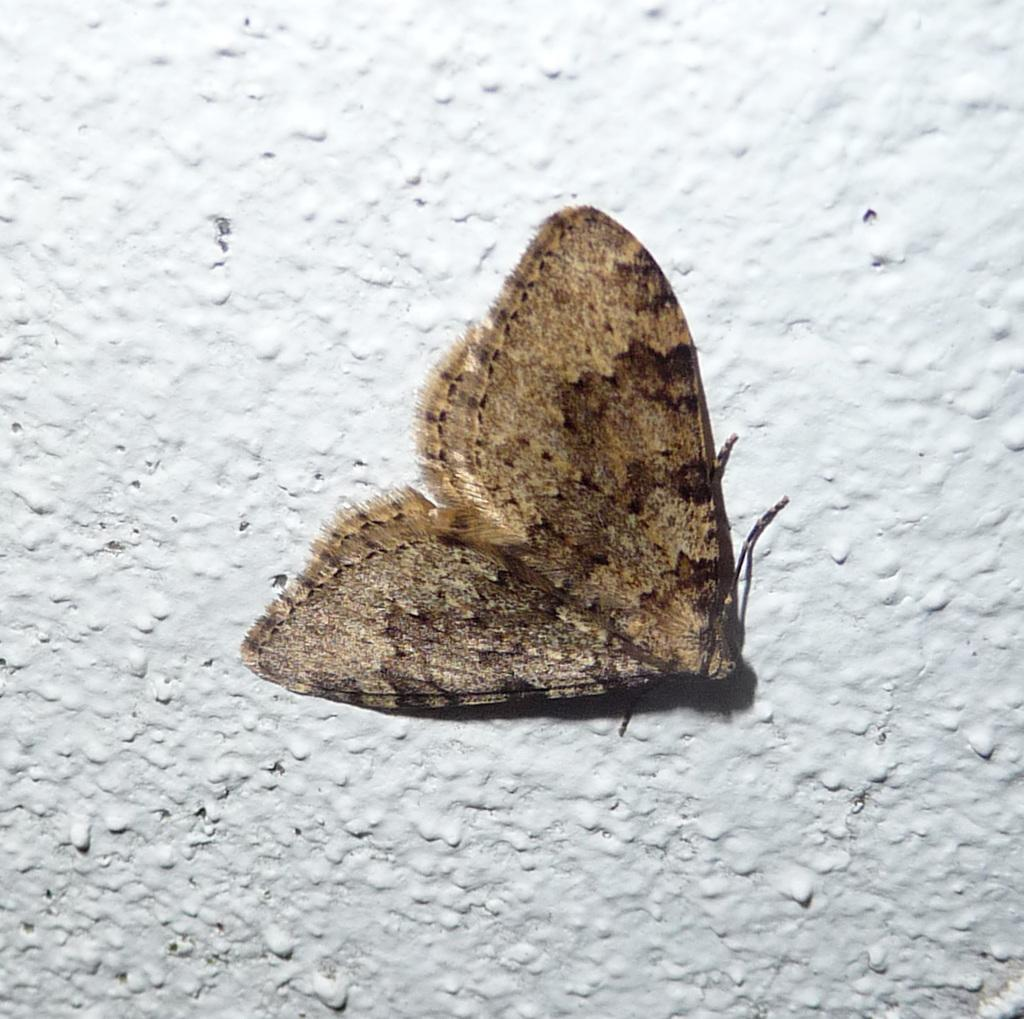What is on the wall in the image? There is a fly on the wall in the image. Where is the kitten playing with a vase and grape in the image? There is no kitten, vase, or grape present in the image; it only features a fly on the wall. 